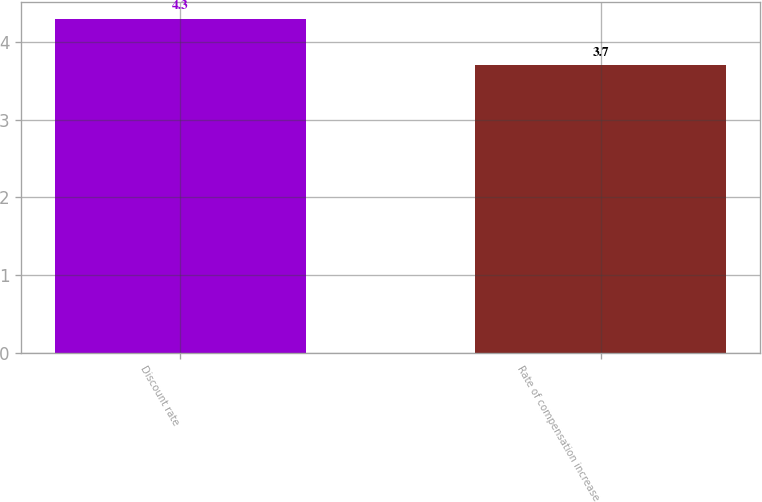Convert chart to OTSL. <chart><loc_0><loc_0><loc_500><loc_500><bar_chart><fcel>Discount rate<fcel>Rate of compensation increase<nl><fcel>4.3<fcel>3.7<nl></chart> 